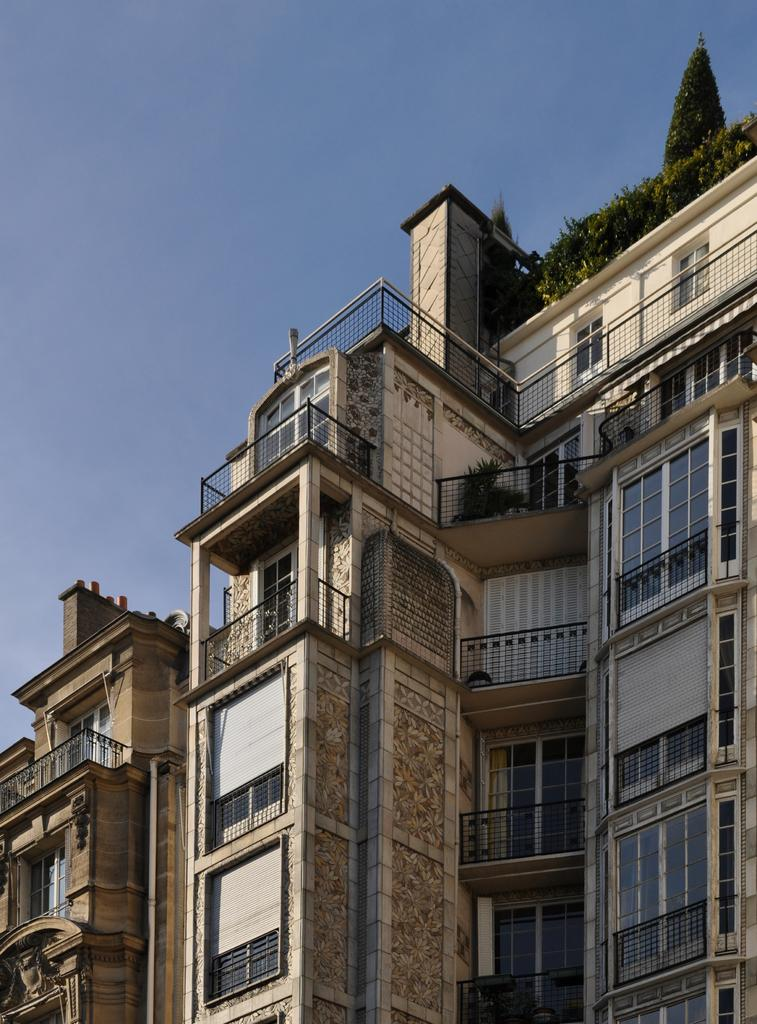What type of structures can be seen in the image? There are buildings in the image. What other elements are present in the image besides buildings? There are plants in the image. What color is the sky in the image? The sky is blue in the image. Can you see a receipt for the carpenter's work in the image? There is no receipt or carpenter present in the image. Is there a baby visible in the image? There is no baby present in the image. 